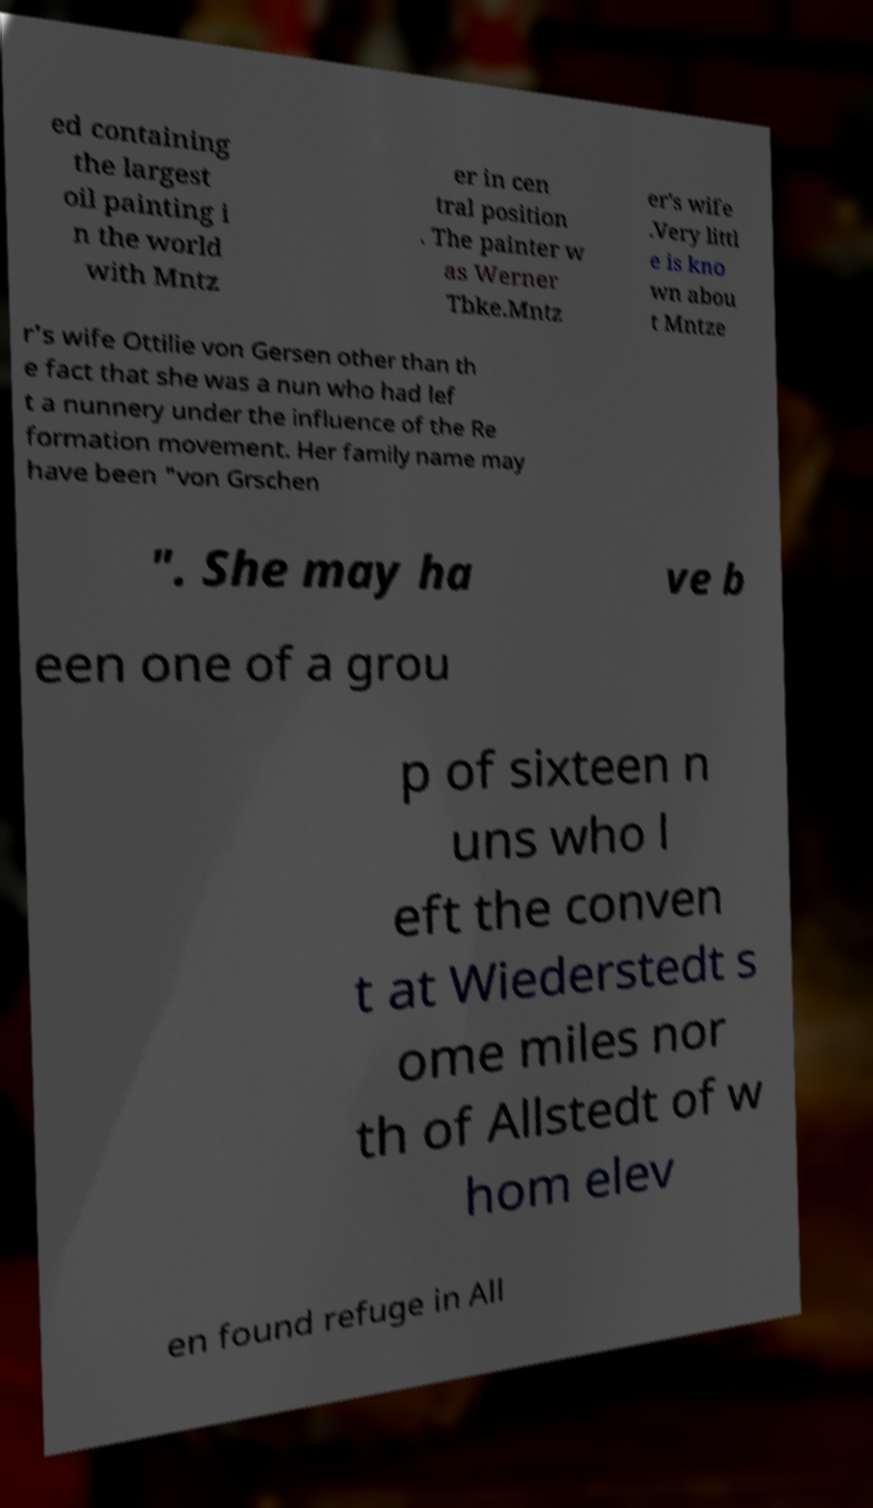Can you read and provide the text displayed in the image?This photo seems to have some interesting text. Can you extract and type it out for me? ed containing the largest oil painting i n the world with Mntz er in cen tral position . The painter w as Werner Tbke.Mntz er's wife .Very littl e is kno wn abou t Mntze r's wife Ottilie von Gersen other than th e fact that she was a nun who had lef t a nunnery under the influence of the Re formation movement. Her family name may have been "von Grschen ". She may ha ve b een one of a grou p of sixteen n uns who l eft the conven t at Wiederstedt s ome miles nor th of Allstedt of w hom elev en found refuge in All 